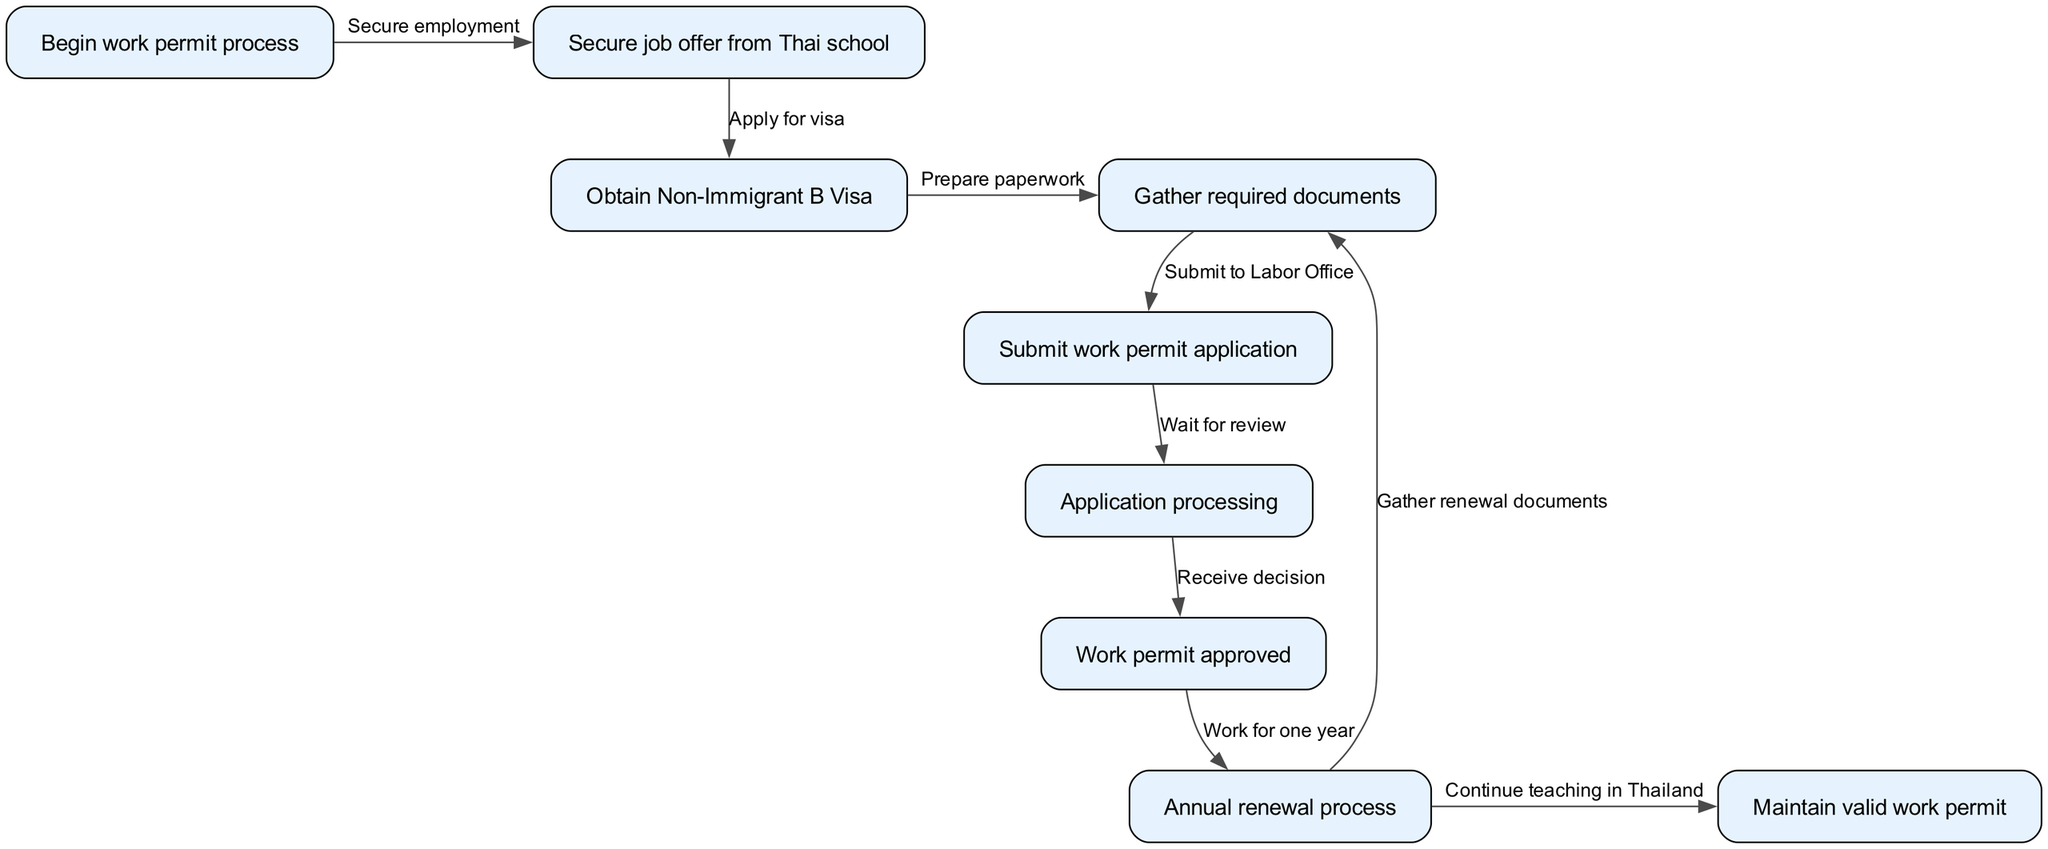What is the first step in the work permit process? The diagram starts with the node labeled "Begin work permit process", which implies this is the initial step to start the entire procedure.
Answer: Begin work permit process How many nodes are present in the diagram? The diagram consists of 9 distinct nodes, each representing a different step in the process of obtaining a Thai work permit.
Answer: 9 What document must be obtained after securing a job offer? After securing a job offer from a Thai school, the next step is to obtain a Non-Immigrant B Visa, as indicated in the flowchart.
Answer: Non-Immigrant B Visa What happens after the work permit is approved? Once the work permit is approved, the next action is to enter the annual renewal process as shown in the diagram, indicating that work permits need to be renewed periodically.
Answer: Annual renewal process What is required before submitting the work permit application? Before submitting the work permit application, the diagram shows that it is necessary to gather the required documents to support the application process.
Answer: Gather required documents How does the renewal process relate to the documentation? In the renewal process, it is required to gather renewal documents, which directly connects the renewal step to the documentation needed for maintaining the work permit validity.
Answer: Gather renewal documents How is the "Application processing" node connected to the "Work permit approved" node? The diagram depicts that after the "Submit work permit application" node, there is a transition to "Application processing", which eventually leads to the "Work permit approved" node upon successful review.
Answer: Receive decision What is the final outcome after completing the renewal process? The last step, after completing the annual renewal process, is to "Continue teaching in Thailand", indicating that the work permit allows the teacher to maintain their employment status legally.
Answer: Continue teaching in Thailand What step comes immediately after waiting for review? After the "Wait for review" step, the next step is "Receive decision", indicating that this is the outcome of the application processing stage.
Answer: Receive decision 